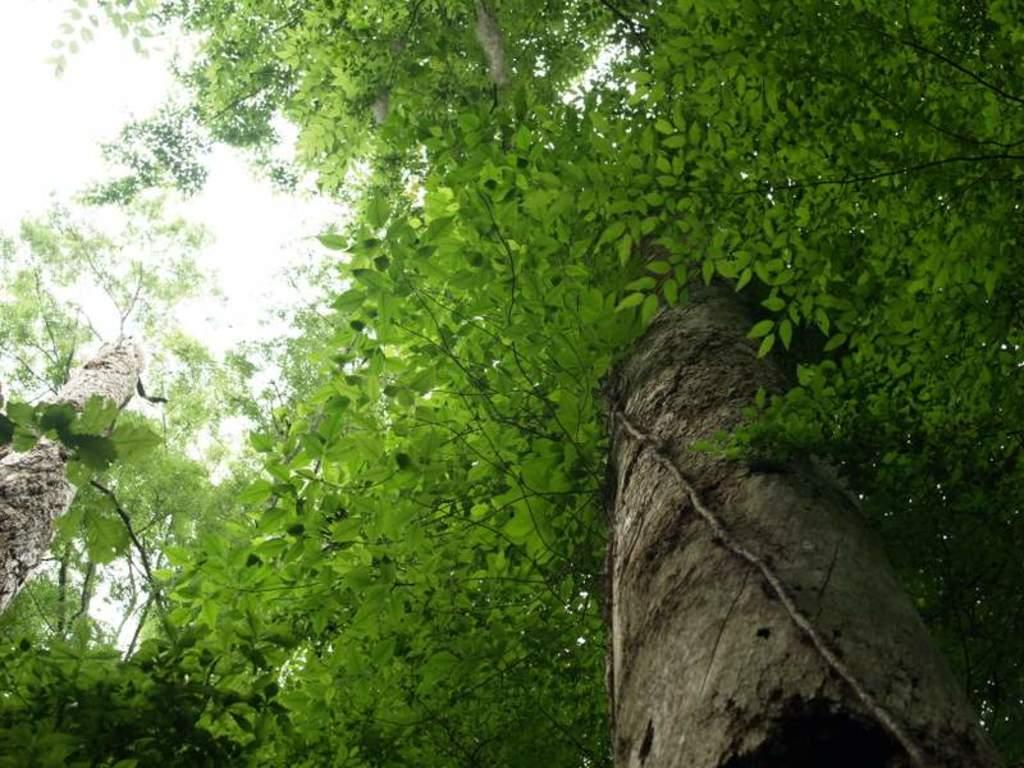What type of vegetation can be seen in the image? There are trees in the image. What is the condition of the sky in the image? The sky is cloudy in the image. Can you tell me how many times the person in the image coughed? There is no person present in the image, so it is not possible to determine how many times they coughed. 